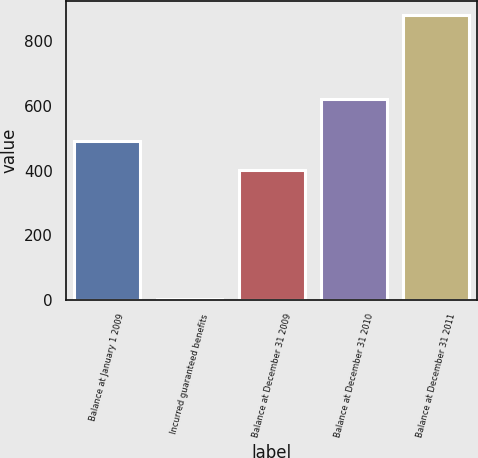<chart> <loc_0><loc_0><loc_500><loc_500><bar_chart><fcel>Balance at January 1 2009<fcel>Incurred guaranteed benefits<fcel>Balance at December 31 2009<fcel>Balance at December 31 2010<fcel>Balance at December 31 2011<nl><fcel>490.1<fcel>1<fcel>402<fcel>623<fcel>882<nl></chart> 